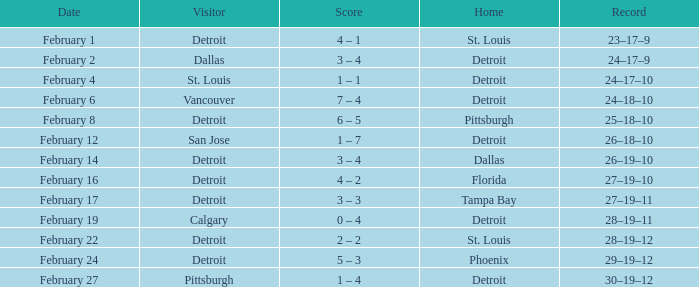What was their performance record during their time at pittsburgh? 25–18–10. 